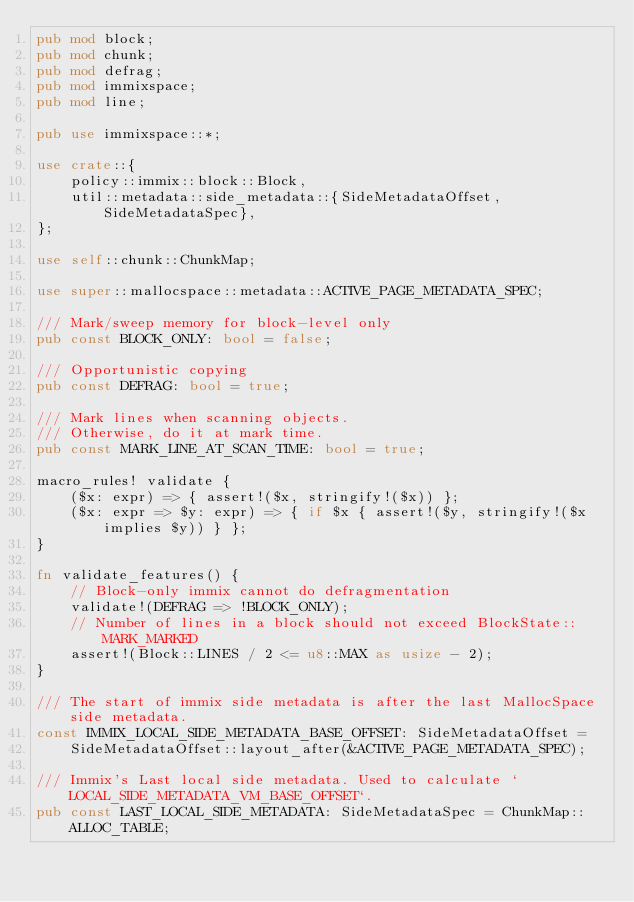Convert code to text. <code><loc_0><loc_0><loc_500><loc_500><_Rust_>pub mod block;
pub mod chunk;
pub mod defrag;
pub mod immixspace;
pub mod line;

pub use immixspace::*;

use crate::{
    policy::immix::block::Block,
    util::metadata::side_metadata::{SideMetadataOffset, SideMetadataSpec},
};

use self::chunk::ChunkMap;

use super::mallocspace::metadata::ACTIVE_PAGE_METADATA_SPEC;

/// Mark/sweep memory for block-level only
pub const BLOCK_ONLY: bool = false;

/// Opportunistic copying
pub const DEFRAG: bool = true;

/// Mark lines when scanning objects.
/// Otherwise, do it at mark time.
pub const MARK_LINE_AT_SCAN_TIME: bool = true;

macro_rules! validate {
    ($x: expr) => { assert!($x, stringify!($x)) };
    ($x: expr => $y: expr) => { if $x { assert!($y, stringify!($x implies $y)) } };
}

fn validate_features() {
    // Block-only immix cannot do defragmentation
    validate!(DEFRAG => !BLOCK_ONLY);
    // Number of lines in a block should not exceed BlockState::MARK_MARKED
    assert!(Block::LINES / 2 <= u8::MAX as usize - 2);
}

/// The start of immix side metadata is after the last MallocSpace side metadata.
const IMMIX_LOCAL_SIDE_METADATA_BASE_OFFSET: SideMetadataOffset =
    SideMetadataOffset::layout_after(&ACTIVE_PAGE_METADATA_SPEC);

/// Immix's Last local side metadata. Used to calculate `LOCAL_SIDE_METADATA_VM_BASE_OFFSET`.
pub const LAST_LOCAL_SIDE_METADATA: SideMetadataSpec = ChunkMap::ALLOC_TABLE;
</code> 